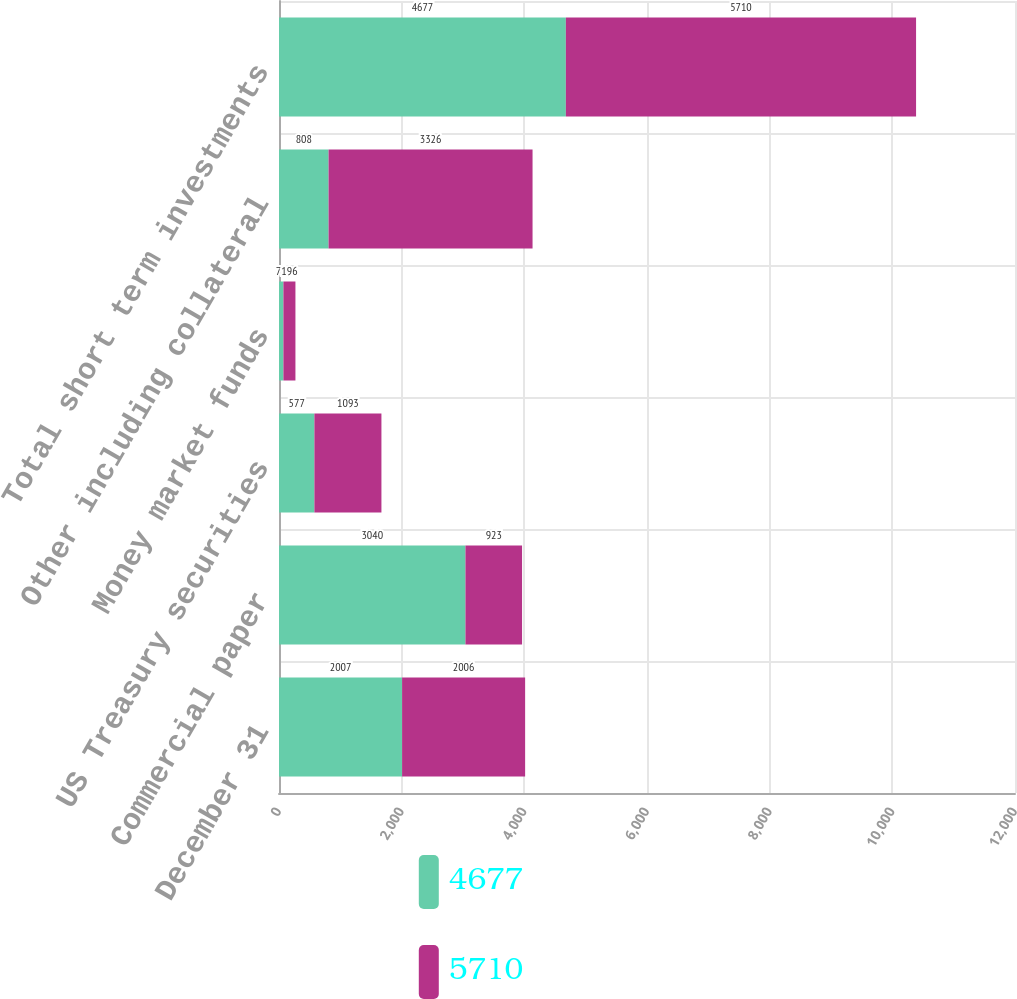Convert chart. <chart><loc_0><loc_0><loc_500><loc_500><stacked_bar_chart><ecel><fcel>December 31<fcel>Commercial paper<fcel>US Treasury securities<fcel>Money market funds<fcel>Other including collateral<fcel>Total short term investments<nl><fcel>4677<fcel>2007<fcel>3040<fcel>577<fcel>72<fcel>808<fcel>4677<nl><fcel>5710<fcel>2006<fcel>923<fcel>1093<fcel>196<fcel>3326<fcel>5710<nl></chart> 